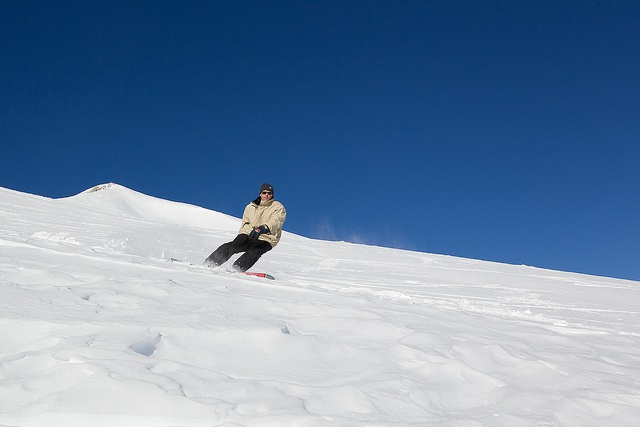Describe the objects in this image and their specific colors. I can see people in navy, black, tan, gray, and darkgray tones and snowboard in navy, lightgray, darkgray, salmon, and gray tones in this image. 